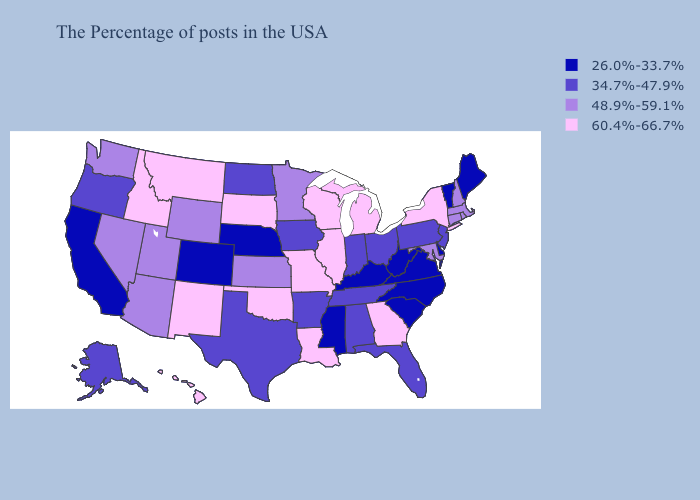Does California have the same value as Vermont?
Concise answer only. Yes. Among the states that border Pennsylvania , does Maryland have the lowest value?
Keep it brief. No. Among the states that border Virginia , which have the highest value?
Short answer required. Maryland. Does the map have missing data?
Write a very short answer. No. What is the value of Mississippi?
Be succinct. 26.0%-33.7%. What is the highest value in the MidWest ?
Give a very brief answer. 60.4%-66.7%. Among the states that border Kansas , which have the lowest value?
Short answer required. Nebraska, Colorado. What is the value of Washington?
Write a very short answer. 48.9%-59.1%. Does North Carolina have the lowest value in the South?
Write a very short answer. Yes. What is the highest value in states that border Kansas?
Be succinct. 60.4%-66.7%. Among the states that border New York , does Vermont have the highest value?
Answer briefly. No. What is the value of South Dakota?
Keep it brief. 60.4%-66.7%. Which states have the lowest value in the MidWest?
Short answer required. Nebraska. Does Idaho have the same value as Montana?
Be succinct. Yes. Among the states that border New Jersey , which have the highest value?
Quick response, please. New York. 